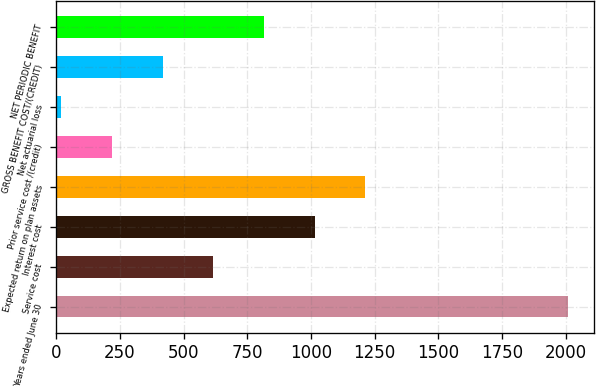Convert chart to OTSL. <chart><loc_0><loc_0><loc_500><loc_500><bar_chart><fcel>Years ended June 30<fcel>Service cost<fcel>Interest cost<fcel>Expected return on plan assets<fcel>Prior service cost /(credit)<fcel>Net actuarial loss<fcel>GROSS BENEFIT COST/(CREDIT)<fcel>NET PERIODIC BENEFIT<nl><fcel>2010<fcel>617<fcel>1015<fcel>1214<fcel>219<fcel>20<fcel>418<fcel>816<nl></chart> 